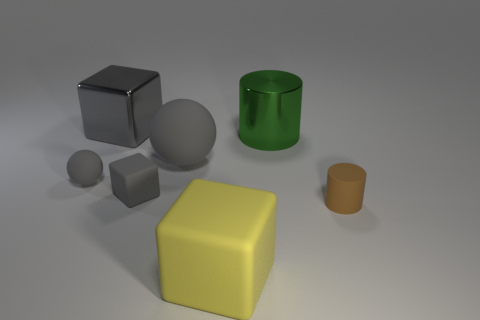What is the shape of the big gray thing that is made of the same material as the tiny brown thing?
Give a very brief answer. Sphere. How many other small brown rubber objects are the same shape as the small brown thing?
Keep it short and to the point. 0. There is a large gray object right of the big gray object that is left of the big gray rubber ball; what shape is it?
Your response must be concise. Sphere. Is the size of the metal object behind the green cylinder the same as the small cylinder?
Provide a short and direct response. No. There is a gray rubber object that is both behind the gray matte block and to the right of the tiny gray matte ball; how big is it?
Provide a short and direct response. Large. What number of green objects have the same size as the green cylinder?
Offer a terse response. 0. How many balls are behind the cylinder in front of the big ball?
Provide a succinct answer. 2. There is a large matte object that is behind the small brown matte thing; is it the same color as the tiny rubber block?
Your answer should be very brief. Yes. Is there a gray metallic object to the left of the gray cube that is in front of the metal object that is to the left of the metal cylinder?
Give a very brief answer. Yes. There is a gray thing that is both behind the tiny gray ball and in front of the gray metallic block; what shape is it?
Provide a succinct answer. Sphere. 